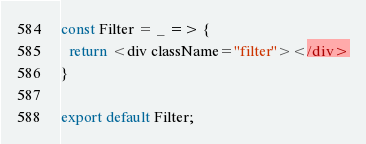<code> <loc_0><loc_0><loc_500><loc_500><_JavaScript_>const Filter = _ => {
  return <div className="filter"></div>
}

export default Filter;</code> 